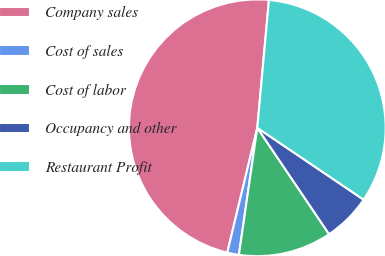Convert chart. <chart><loc_0><loc_0><loc_500><loc_500><pie_chart><fcel>Company sales<fcel>Cost of sales<fcel>Cost of labor<fcel>Occupancy and other<fcel>Restaurant Profit<nl><fcel>47.69%<fcel>1.47%<fcel>11.74%<fcel>6.09%<fcel>33.02%<nl></chart> 